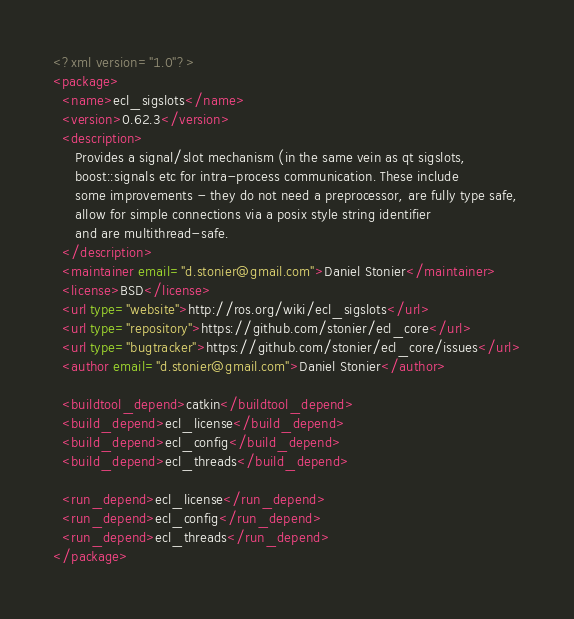<code> <loc_0><loc_0><loc_500><loc_500><_XML_><?xml version="1.0"?>
<package>
  <name>ecl_sigslots</name>
  <version>0.62.3</version>
  <description>
     Provides a signal/slot mechanism (in the same vein as qt sigslots, 
     boost::signals etc for intra-process communication. These include 
     some improvements - they do not need a preprocessor, are fully type safe,
     allow for simple connections via a posix style string identifier 
     and are multithread-safe.
  </description>
  <maintainer email="d.stonier@gmail.com">Daniel Stonier</maintainer>
  <license>BSD</license>
  <url type="website">http://ros.org/wiki/ecl_sigslots</url>
  <url type="repository">https://github.com/stonier/ecl_core</url>
  <url type="bugtracker">https://github.com/stonier/ecl_core/issues</url>
  <author email="d.stonier@gmail.com">Daniel Stonier</author>

  <buildtool_depend>catkin</buildtool_depend>
  <build_depend>ecl_license</build_depend>
  <build_depend>ecl_config</build_depend>
  <build_depend>ecl_threads</build_depend>
  
  <run_depend>ecl_license</run_depend>
  <run_depend>ecl_config</run_depend>
  <run_depend>ecl_threads</run_depend>
</package>


</code> 